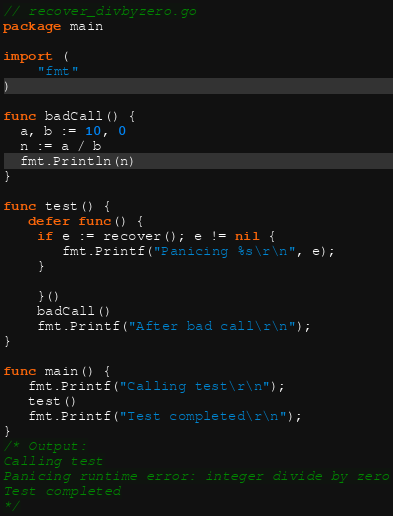Convert code to text. <code><loc_0><loc_0><loc_500><loc_500><_Go_>// recover_divbyzero.go
package main

import (
	"fmt"
)

func badCall() {
  a, b := 10, 0
  n := a / b
  fmt.Println(n)
}

func test() {
   defer func() { 
    if e := recover(); e != nil {
       fmt.Printf("Panicing %s\r\n", e);
    }
   
    }()
    badCall()
    fmt.Printf("After bad call\r\n");
}

func main() {
   fmt.Printf("Calling test\r\n");
   test()
   fmt.Printf("Test completed\r\n");
}
/* Output:
Calling test
Panicing runtime error: integer divide by zero
Test completed
*/
</code> 